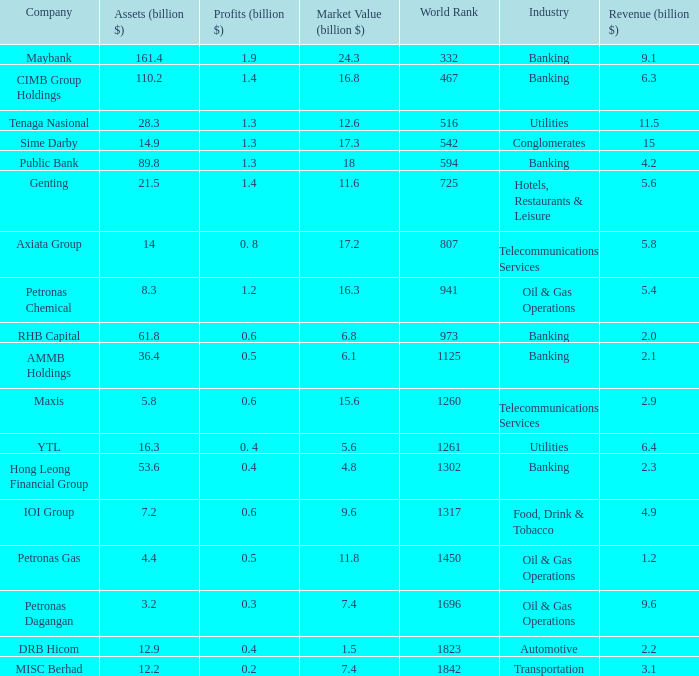Name the market value for rhb capital 6.8. 